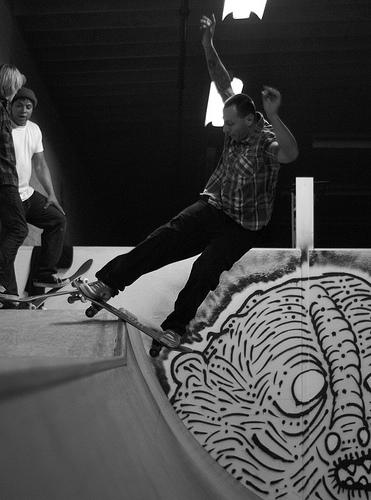What type of print is the man raising his hands wearing on his shirt? plaid 